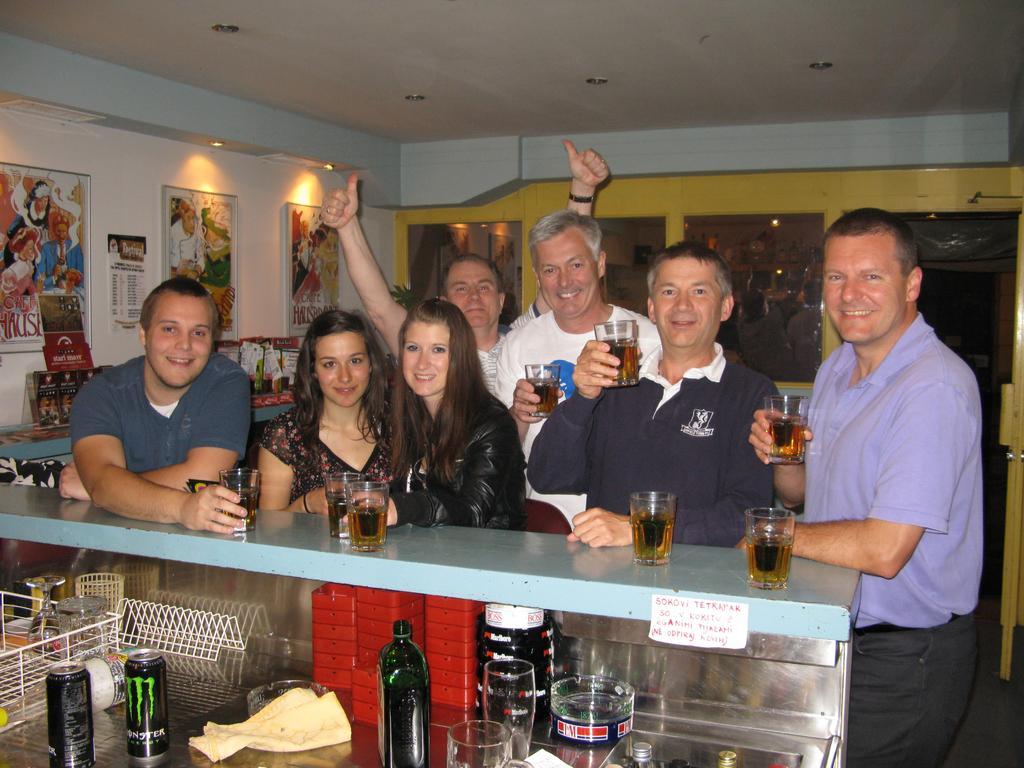In one or two sentences, can you explain what this image depicts? In this image i can see there are the group of persons standing in front of a table they are holding a glass on the wall there is a photo frame attached to the wall 